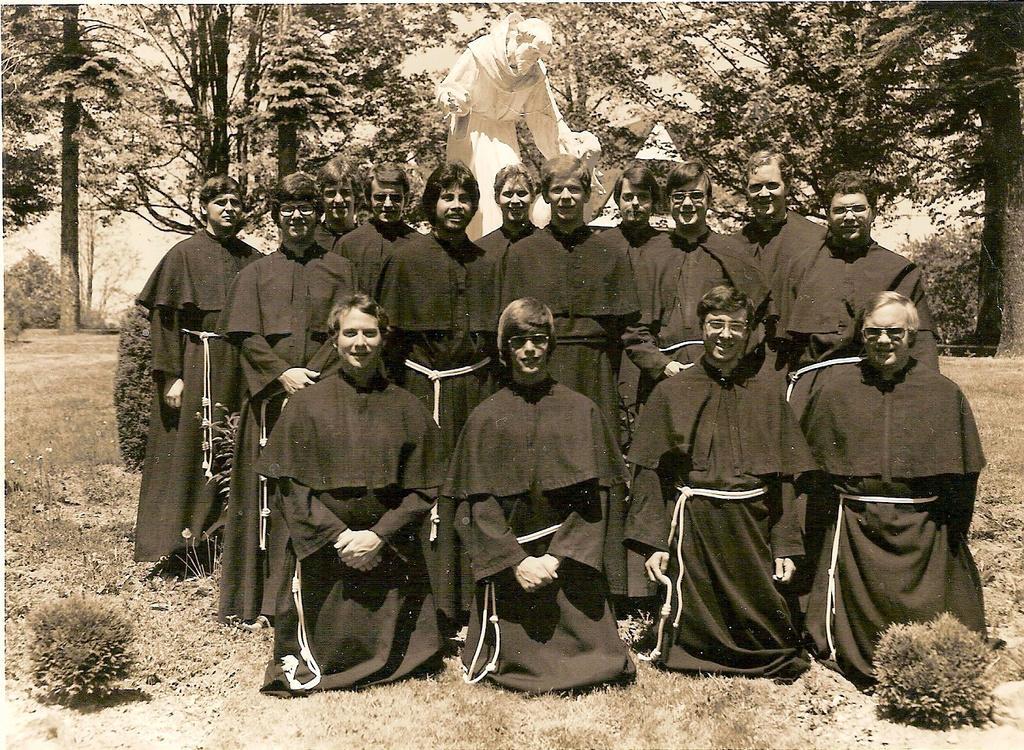In one or two sentences, can you explain what this image depicts? In the foreground of the picture I can see a group of people and they are wearing the black color clothes. There is a smile on their face and I can see a few of them wearing the spectacles. There is a person at the top of the picture and he is wearing white clothes. In the background, I can see the trees. 